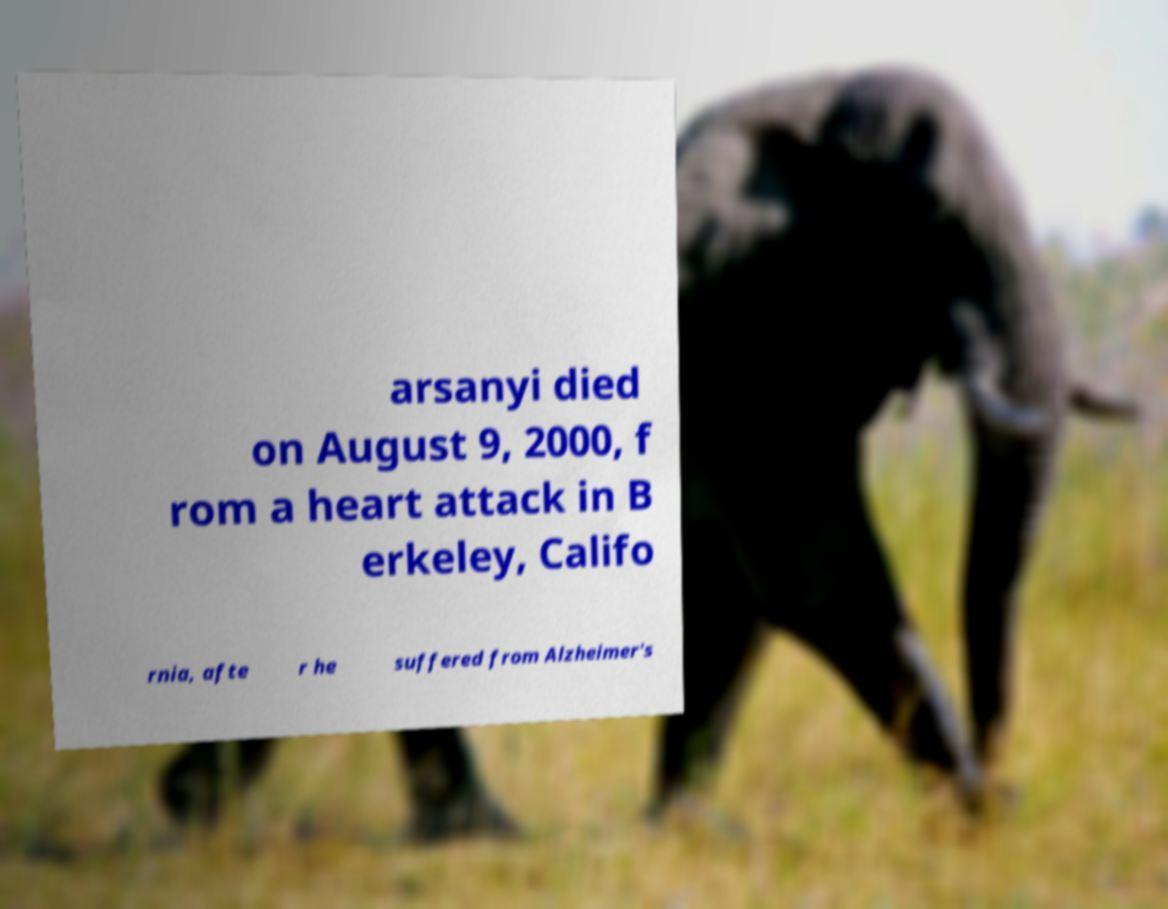Could you assist in decoding the text presented in this image and type it out clearly? arsanyi died on August 9, 2000, f rom a heart attack in B erkeley, Califo rnia, afte r he suffered from Alzheimer's 